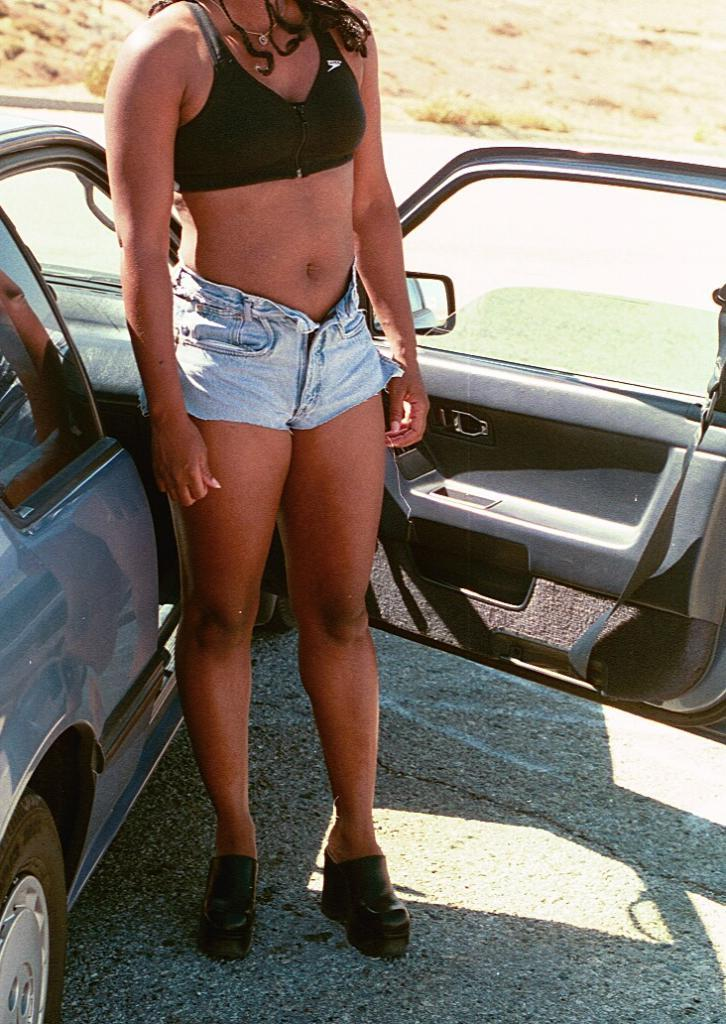Who is the main subject in the image? There is a woman standing in the middle of the image. What else can be seen on the left side of the image? There is a car on the left side of the image. How many cows are grazing in the background of the image? There are no cows present in the image. What type of things can be seen in the image besides the woman and the car? The image only shows a woman and a car, so there are no other things visible. 